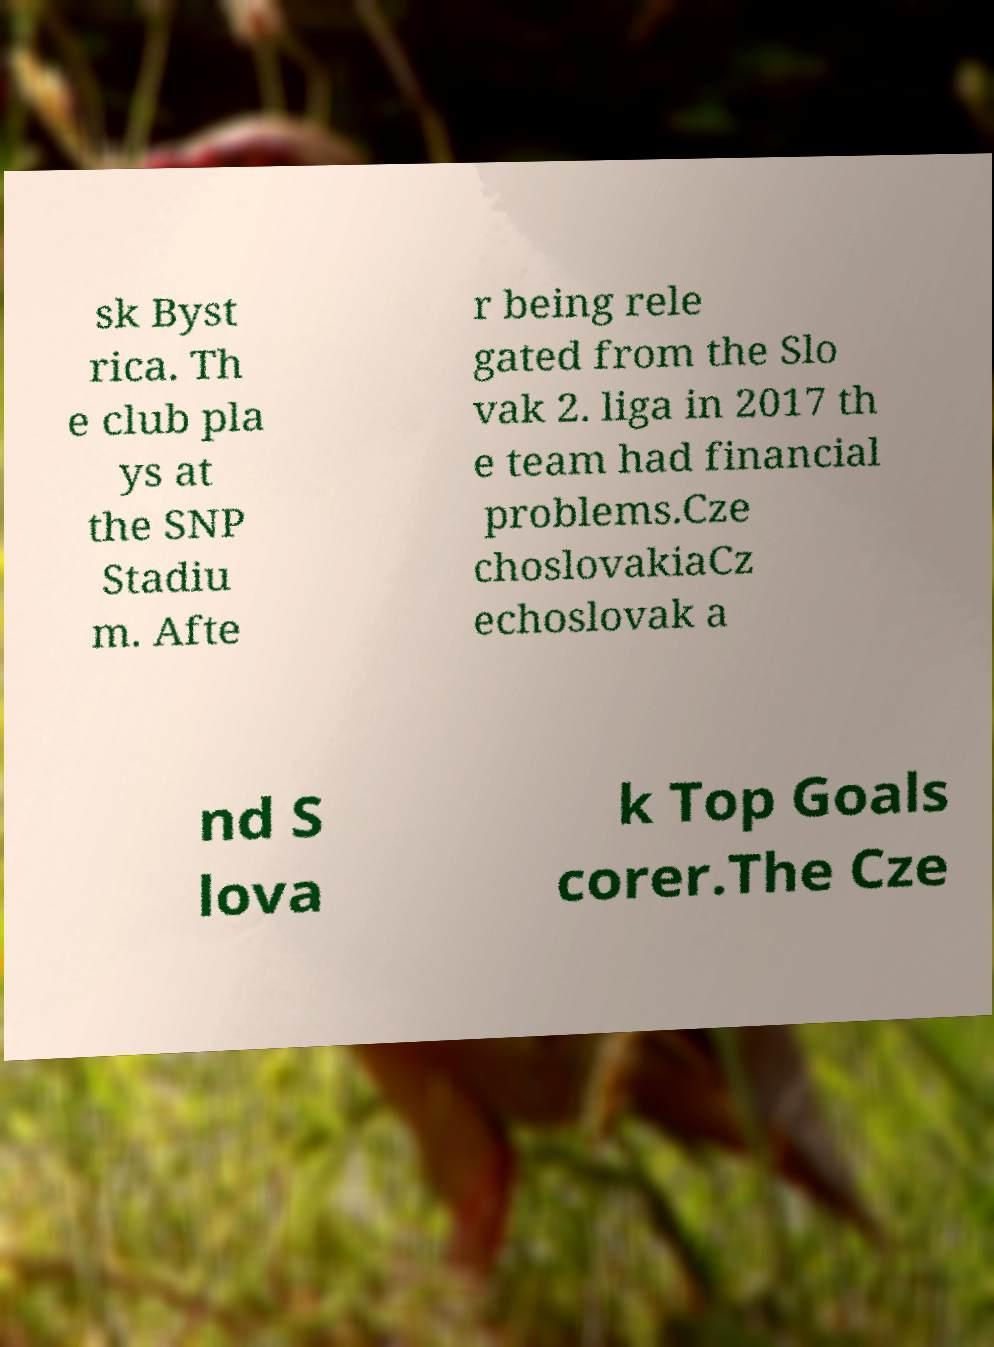What messages or text are displayed in this image? I need them in a readable, typed format. sk Byst rica. Th e club pla ys at the SNP Stadiu m. Afte r being rele gated from the Slo vak 2. liga in 2017 th e team had financial problems.Cze choslovakiaCz echoslovak a nd S lova k Top Goals corer.The Cze 